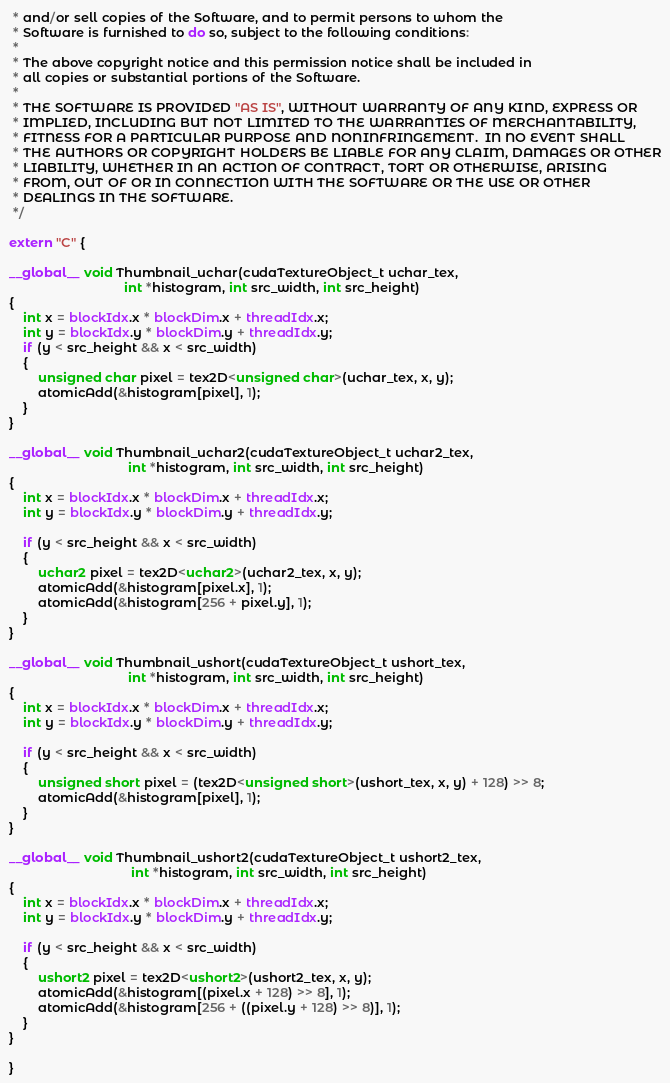Convert code to text. <code><loc_0><loc_0><loc_500><loc_500><_Cuda_> * and/or sell copies of the Software, and to permit persons to whom the
 * Software is furnished to do so, subject to the following conditions:
 *
 * The above copyright notice and this permission notice shall be included in
 * all copies or substantial portions of the Software.
 *
 * THE SOFTWARE IS PROVIDED "AS IS", WITHOUT WARRANTY OF ANY KIND, EXPRESS OR
 * IMPLIED, INCLUDING BUT NOT LIMITED TO THE WARRANTIES OF MERCHANTABILITY,
 * FITNESS FOR A PARTICULAR PURPOSE AND NONINFRINGEMENT.  IN NO EVENT SHALL
 * THE AUTHORS OR COPYRIGHT HOLDERS BE LIABLE FOR ANY CLAIM, DAMAGES OR OTHER
 * LIABILITY, WHETHER IN AN ACTION OF CONTRACT, TORT OR OTHERWISE, ARISING
 * FROM, OUT OF OR IN CONNECTION WITH THE SOFTWARE OR THE USE OR OTHER
 * DEALINGS IN THE SOFTWARE.
 */

extern "C" {

__global__ void Thumbnail_uchar(cudaTextureObject_t uchar_tex,
                                int *histogram, int src_width, int src_height)
{
    int x = blockIdx.x * blockDim.x + threadIdx.x;
    int y = blockIdx.y * blockDim.y + threadIdx.y;
    if (y < src_height && x < src_width)
    {
        unsigned char pixel = tex2D<unsigned char>(uchar_tex, x, y);
        atomicAdd(&histogram[pixel], 1);
    }
}

__global__ void Thumbnail_uchar2(cudaTextureObject_t uchar2_tex,
                                 int *histogram, int src_width, int src_height)
{
    int x = blockIdx.x * blockDim.x + threadIdx.x;
    int y = blockIdx.y * blockDim.y + threadIdx.y;

    if (y < src_height && x < src_width)
    {
        uchar2 pixel = tex2D<uchar2>(uchar2_tex, x, y);
        atomicAdd(&histogram[pixel.x], 1);
        atomicAdd(&histogram[256 + pixel.y], 1);
    }
}

__global__ void Thumbnail_ushort(cudaTextureObject_t ushort_tex,
                                 int *histogram, int src_width, int src_height)
{
    int x = blockIdx.x * blockDim.x + threadIdx.x;
    int y = blockIdx.y * blockDim.y + threadIdx.y;

    if (y < src_height && x < src_width)
    {
        unsigned short pixel = (tex2D<unsigned short>(ushort_tex, x, y) + 128) >> 8;
        atomicAdd(&histogram[pixel], 1);
    }
}

__global__ void Thumbnail_ushort2(cudaTextureObject_t ushort2_tex,
                                  int *histogram, int src_width, int src_height)
{
    int x = blockIdx.x * blockDim.x + threadIdx.x;
    int y = blockIdx.y * blockDim.y + threadIdx.y;

    if (y < src_height && x < src_width)
    {
        ushort2 pixel = tex2D<ushort2>(ushort2_tex, x, y);
        atomicAdd(&histogram[(pixel.x + 128) >> 8], 1);
        atomicAdd(&histogram[256 + ((pixel.y + 128) >> 8)], 1);
    }
}

}
</code> 